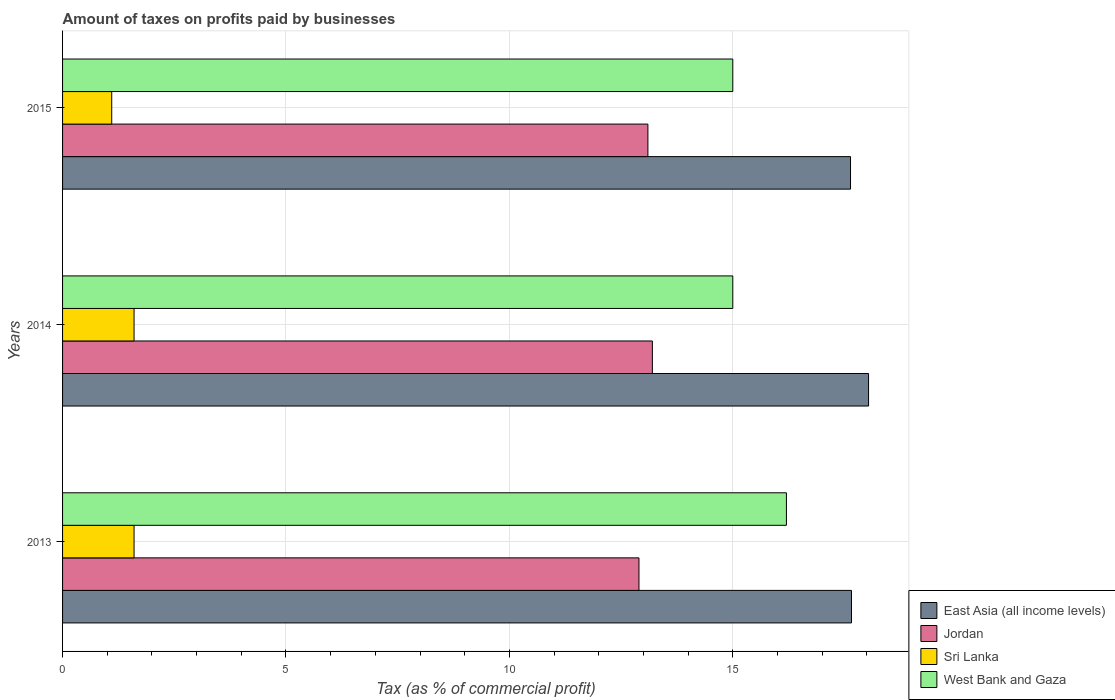How many different coloured bars are there?
Make the answer very short. 4. Are the number of bars per tick equal to the number of legend labels?
Make the answer very short. Yes. What is the label of the 2nd group of bars from the top?
Give a very brief answer. 2014. In how many cases, is the number of bars for a given year not equal to the number of legend labels?
Ensure brevity in your answer.  0. What is the percentage of taxes paid by businesses in Sri Lanka in 2014?
Your response must be concise. 1.6. Across all years, what is the maximum percentage of taxes paid by businesses in East Asia (all income levels)?
Your answer should be very brief. 18.04. In which year was the percentage of taxes paid by businesses in Sri Lanka maximum?
Give a very brief answer. 2013. What is the total percentage of taxes paid by businesses in West Bank and Gaza in the graph?
Provide a succinct answer. 46.2. What is the difference between the percentage of taxes paid by businesses in East Asia (all income levels) in 2014 and the percentage of taxes paid by businesses in West Bank and Gaza in 2013?
Give a very brief answer. 1.84. What is the average percentage of taxes paid by businesses in West Bank and Gaza per year?
Your answer should be very brief. 15.4. In the year 2014, what is the difference between the percentage of taxes paid by businesses in East Asia (all income levels) and percentage of taxes paid by businesses in Jordan?
Keep it short and to the point. 4.84. What is the ratio of the percentage of taxes paid by businesses in West Bank and Gaza in 2014 to that in 2015?
Ensure brevity in your answer.  1. Is the percentage of taxes paid by businesses in Sri Lanka in 2014 less than that in 2015?
Your answer should be very brief. No. What is the difference between the highest and the second highest percentage of taxes paid by businesses in West Bank and Gaza?
Your response must be concise. 1.2. What is the difference between the highest and the lowest percentage of taxes paid by businesses in Jordan?
Provide a succinct answer. 0.3. Is the sum of the percentage of taxes paid by businesses in West Bank and Gaza in 2013 and 2014 greater than the maximum percentage of taxes paid by businesses in East Asia (all income levels) across all years?
Make the answer very short. Yes. Is it the case that in every year, the sum of the percentage of taxes paid by businesses in East Asia (all income levels) and percentage of taxes paid by businesses in West Bank and Gaza is greater than the sum of percentage of taxes paid by businesses in Jordan and percentage of taxes paid by businesses in Sri Lanka?
Provide a short and direct response. Yes. What does the 4th bar from the top in 2013 represents?
Make the answer very short. East Asia (all income levels). What does the 1st bar from the bottom in 2013 represents?
Make the answer very short. East Asia (all income levels). Is it the case that in every year, the sum of the percentage of taxes paid by businesses in Jordan and percentage of taxes paid by businesses in Sri Lanka is greater than the percentage of taxes paid by businesses in East Asia (all income levels)?
Your answer should be very brief. No. Are all the bars in the graph horizontal?
Your answer should be compact. Yes. Are the values on the major ticks of X-axis written in scientific E-notation?
Provide a short and direct response. No. Does the graph contain grids?
Keep it short and to the point. Yes. Where does the legend appear in the graph?
Provide a short and direct response. Bottom right. How many legend labels are there?
Your response must be concise. 4. How are the legend labels stacked?
Keep it short and to the point. Vertical. What is the title of the graph?
Your answer should be compact. Amount of taxes on profits paid by businesses. Does "Equatorial Guinea" appear as one of the legend labels in the graph?
Your response must be concise. No. What is the label or title of the X-axis?
Make the answer very short. Tax (as % of commercial profit). What is the Tax (as % of commercial profit) in East Asia (all income levels) in 2013?
Ensure brevity in your answer.  17.66. What is the Tax (as % of commercial profit) of Jordan in 2013?
Your answer should be very brief. 12.9. What is the Tax (as % of commercial profit) of West Bank and Gaza in 2013?
Provide a succinct answer. 16.2. What is the Tax (as % of commercial profit) of East Asia (all income levels) in 2014?
Provide a succinct answer. 18.04. What is the Tax (as % of commercial profit) in Sri Lanka in 2014?
Give a very brief answer. 1.6. What is the Tax (as % of commercial profit) in West Bank and Gaza in 2014?
Your answer should be compact. 15. What is the Tax (as % of commercial profit) in East Asia (all income levels) in 2015?
Your response must be concise. 17.63. What is the Tax (as % of commercial profit) in West Bank and Gaza in 2015?
Provide a succinct answer. 15. Across all years, what is the maximum Tax (as % of commercial profit) in East Asia (all income levels)?
Your answer should be very brief. 18.04. Across all years, what is the maximum Tax (as % of commercial profit) in Jordan?
Offer a terse response. 13.2. Across all years, what is the maximum Tax (as % of commercial profit) of Sri Lanka?
Provide a short and direct response. 1.6. Across all years, what is the maximum Tax (as % of commercial profit) of West Bank and Gaza?
Your response must be concise. 16.2. Across all years, what is the minimum Tax (as % of commercial profit) of East Asia (all income levels)?
Your answer should be very brief. 17.63. Across all years, what is the minimum Tax (as % of commercial profit) of West Bank and Gaza?
Offer a very short reply. 15. What is the total Tax (as % of commercial profit) in East Asia (all income levels) in the graph?
Ensure brevity in your answer.  53.33. What is the total Tax (as % of commercial profit) of Jordan in the graph?
Keep it short and to the point. 39.2. What is the total Tax (as % of commercial profit) of West Bank and Gaza in the graph?
Provide a succinct answer. 46.2. What is the difference between the Tax (as % of commercial profit) in East Asia (all income levels) in 2013 and that in 2014?
Provide a succinct answer. -0.38. What is the difference between the Tax (as % of commercial profit) in Jordan in 2013 and that in 2014?
Keep it short and to the point. -0.3. What is the difference between the Tax (as % of commercial profit) of West Bank and Gaza in 2013 and that in 2014?
Ensure brevity in your answer.  1.2. What is the difference between the Tax (as % of commercial profit) of East Asia (all income levels) in 2013 and that in 2015?
Ensure brevity in your answer.  0.02. What is the difference between the Tax (as % of commercial profit) in Sri Lanka in 2013 and that in 2015?
Your response must be concise. 0.5. What is the difference between the Tax (as % of commercial profit) of West Bank and Gaza in 2013 and that in 2015?
Ensure brevity in your answer.  1.2. What is the difference between the Tax (as % of commercial profit) in East Asia (all income levels) in 2014 and that in 2015?
Keep it short and to the point. 0.4. What is the difference between the Tax (as % of commercial profit) in East Asia (all income levels) in 2013 and the Tax (as % of commercial profit) in Jordan in 2014?
Make the answer very short. 4.46. What is the difference between the Tax (as % of commercial profit) of East Asia (all income levels) in 2013 and the Tax (as % of commercial profit) of Sri Lanka in 2014?
Your answer should be very brief. 16.06. What is the difference between the Tax (as % of commercial profit) in East Asia (all income levels) in 2013 and the Tax (as % of commercial profit) in West Bank and Gaza in 2014?
Keep it short and to the point. 2.66. What is the difference between the Tax (as % of commercial profit) of Sri Lanka in 2013 and the Tax (as % of commercial profit) of West Bank and Gaza in 2014?
Make the answer very short. -13.4. What is the difference between the Tax (as % of commercial profit) of East Asia (all income levels) in 2013 and the Tax (as % of commercial profit) of Jordan in 2015?
Give a very brief answer. 4.56. What is the difference between the Tax (as % of commercial profit) in East Asia (all income levels) in 2013 and the Tax (as % of commercial profit) in Sri Lanka in 2015?
Give a very brief answer. 16.56. What is the difference between the Tax (as % of commercial profit) of East Asia (all income levels) in 2013 and the Tax (as % of commercial profit) of West Bank and Gaza in 2015?
Your answer should be compact. 2.66. What is the difference between the Tax (as % of commercial profit) in Jordan in 2013 and the Tax (as % of commercial profit) in Sri Lanka in 2015?
Your answer should be compact. 11.8. What is the difference between the Tax (as % of commercial profit) of Jordan in 2013 and the Tax (as % of commercial profit) of West Bank and Gaza in 2015?
Provide a succinct answer. -2.1. What is the difference between the Tax (as % of commercial profit) of Sri Lanka in 2013 and the Tax (as % of commercial profit) of West Bank and Gaza in 2015?
Give a very brief answer. -13.4. What is the difference between the Tax (as % of commercial profit) of East Asia (all income levels) in 2014 and the Tax (as % of commercial profit) of Jordan in 2015?
Give a very brief answer. 4.94. What is the difference between the Tax (as % of commercial profit) of East Asia (all income levels) in 2014 and the Tax (as % of commercial profit) of Sri Lanka in 2015?
Offer a terse response. 16.94. What is the difference between the Tax (as % of commercial profit) of East Asia (all income levels) in 2014 and the Tax (as % of commercial profit) of West Bank and Gaza in 2015?
Provide a short and direct response. 3.04. What is the difference between the Tax (as % of commercial profit) of Jordan in 2014 and the Tax (as % of commercial profit) of Sri Lanka in 2015?
Your answer should be very brief. 12.1. What is the difference between the Tax (as % of commercial profit) of Jordan in 2014 and the Tax (as % of commercial profit) of West Bank and Gaza in 2015?
Make the answer very short. -1.8. What is the difference between the Tax (as % of commercial profit) of Sri Lanka in 2014 and the Tax (as % of commercial profit) of West Bank and Gaza in 2015?
Offer a very short reply. -13.4. What is the average Tax (as % of commercial profit) of East Asia (all income levels) per year?
Keep it short and to the point. 17.78. What is the average Tax (as % of commercial profit) of Jordan per year?
Offer a terse response. 13.07. What is the average Tax (as % of commercial profit) of Sri Lanka per year?
Offer a terse response. 1.43. What is the average Tax (as % of commercial profit) of West Bank and Gaza per year?
Make the answer very short. 15.4. In the year 2013, what is the difference between the Tax (as % of commercial profit) in East Asia (all income levels) and Tax (as % of commercial profit) in Jordan?
Make the answer very short. 4.76. In the year 2013, what is the difference between the Tax (as % of commercial profit) in East Asia (all income levels) and Tax (as % of commercial profit) in Sri Lanka?
Give a very brief answer. 16.06. In the year 2013, what is the difference between the Tax (as % of commercial profit) in East Asia (all income levels) and Tax (as % of commercial profit) in West Bank and Gaza?
Offer a very short reply. 1.46. In the year 2013, what is the difference between the Tax (as % of commercial profit) of Jordan and Tax (as % of commercial profit) of Sri Lanka?
Keep it short and to the point. 11.3. In the year 2013, what is the difference between the Tax (as % of commercial profit) of Jordan and Tax (as % of commercial profit) of West Bank and Gaza?
Your answer should be compact. -3.3. In the year 2013, what is the difference between the Tax (as % of commercial profit) in Sri Lanka and Tax (as % of commercial profit) in West Bank and Gaza?
Provide a short and direct response. -14.6. In the year 2014, what is the difference between the Tax (as % of commercial profit) of East Asia (all income levels) and Tax (as % of commercial profit) of Jordan?
Offer a very short reply. 4.84. In the year 2014, what is the difference between the Tax (as % of commercial profit) in East Asia (all income levels) and Tax (as % of commercial profit) in Sri Lanka?
Offer a terse response. 16.44. In the year 2014, what is the difference between the Tax (as % of commercial profit) of East Asia (all income levels) and Tax (as % of commercial profit) of West Bank and Gaza?
Your answer should be very brief. 3.04. In the year 2014, what is the difference between the Tax (as % of commercial profit) of Jordan and Tax (as % of commercial profit) of Sri Lanka?
Your answer should be very brief. 11.6. In the year 2015, what is the difference between the Tax (as % of commercial profit) of East Asia (all income levels) and Tax (as % of commercial profit) of Jordan?
Offer a terse response. 4.53. In the year 2015, what is the difference between the Tax (as % of commercial profit) in East Asia (all income levels) and Tax (as % of commercial profit) in Sri Lanka?
Provide a short and direct response. 16.53. In the year 2015, what is the difference between the Tax (as % of commercial profit) of East Asia (all income levels) and Tax (as % of commercial profit) of West Bank and Gaza?
Provide a short and direct response. 2.63. What is the ratio of the Tax (as % of commercial profit) of East Asia (all income levels) in 2013 to that in 2014?
Ensure brevity in your answer.  0.98. What is the ratio of the Tax (as % of commercial profit) in Jordan in 2013 to that in 2014?
Make the answer very short. 0.98. What is the ratio of the Tax (as % of commercial profit) of West Bank and Gaza in 2013 to that in 2014?
Give a very brief answer. 1.08. What is the ratio of the Tax (as % of commercial profit) of Jordan in 2013 to that in 2015?
Give a very brief answer. 0.98. What is the ratio of the Tax (as % of commercial profit) of Sri Lanka in 2013 to that in 2015?
Give a very brief answer. 1.45. What is the ratio of the Tax (as % of commercial profit) in East Asia (all income levels) in 2014 to that in 2015?
Make the answer very short. 1.02. What is the ratio of the Tax (as % of commercial profit) in Jordan in 2014 to that in 2015?
Provide a short and direct response. 1.01. What is the ratio of the Tax (as % of commercial profit) of Sri Lanka in 2014 to that in 2015?
Offer a very short reply. 1.45. What is the difference between the highest and the second highest Tax (as % of commercial profit) of East Asia (all income levels)?
Your response must be concise. 0.38. What is the difference between the highest and the lowest Tax (as % of commercial profit) of East Asia (all income levels)?
Offer a terse response. 0.4. What is the difference between the highest and the lowest Tax (as % of commercial profit) of Sri Lanka?
Offer a very short reply. 0.5. What is the difference between the highest and the lowest Tax (as % of commercial profit) of West Bank and Gaza?
Provide a succinct answer. 1.2. 